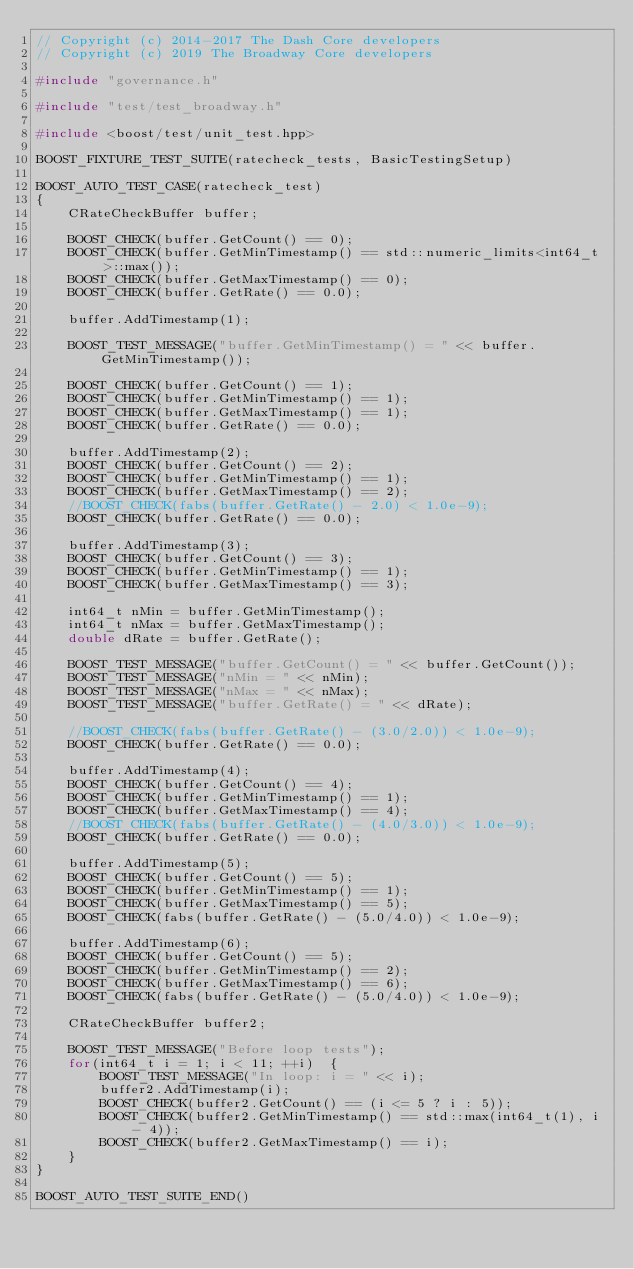Convert code to text. <code><loc_0><loc_0><loc_500><loc_500><_C++_>// Copyright (c) 2014-2017 The Dash Core developers
// Copyright (c) 2019 The Broadway Core developers

#include "governance.h"

#include "test/test_broadway.h"

#include <boost/test/unit_test.hpp>

BOOST_FIXTURE_TEST_SUITE(ratecheck_tests, BasicTestingSetup)

BOOST_AUTO_TEST_CASE(ratecheck_test)
{
    CRateCheckBuffer buffer;

    BOOST_CHECK(buffer.GetCount() == 0);
    BOOST_CHECK(buffer.GetMinTimestamp() == std::numeric_limits<int64_t>::max());
    BOOST_CHECK(buffer.GetMaxTimestamp() == 0);
    BOOST_CHECK(buffer.GetRate() == 0.0);

    buffer.AddTimestamp(1);

    BOOST_TEST_MESSAGE("buffer.GetMinTimestamp() = " << buffer.GetMinTimestamp());

    BOOST_CHECK(buffer.GetCount() == 1);
    BOOST_CHECK(buffer.GetMinTimestamp() == 1);
    BOOST_CHECK(buffer.GetMaxTimestamp() == 1);
    BOOST_CHECK(buffer.GetRate() == 0.0);

    buffer.AddTimestamp(2);
    BOOST_CHECK(buffer.GetCount() == 2);
    BOOST_CHECK(buffer.GetMinTimestamp() == 1);
    BOOST_CHECK(buffer.GetMaxTimestamp() == 2);
    //BOOST_CHECK(fabs(buffer.GetRate() - 2.0) < 1.0e-9);
    BOOST_CHECK(buffer.GetRate() == 0.0);

    buffer.AddTimestamp(3);
    BOOST_CHECK(buffer.GetCount() == 3);
    BOOST_CHECK(buffer.GetMinTimestamp() == 1);
    BOOST_CHECK(buffer.GetMaxTimestamp() == 3);

    int64_t nMin = buffer.GetMinTimestamp();
    int64_t nMax = buffer.GetMaxTimestamp();
    double dRate = buffer.GetRate();

    BOOST_TEST_MESSAGE("buffer.GetCount() = " << buffer.GetCount());
    BOOST_TEST_MESSAGE("nMin = " << nMin);
    BOOST_TEST_MESSAGE("nMax = " << nMax);
    BOOST_TEST_MESSAGE("buffer.GetRate() = " << dRate);

    //BOOST_CHECK(fabs(buffer.GetRate() - (3.0/2.0)) < 1.0e-9);
    BOOST_CHECK(buffer.GetRate() == 0.0);

    buffer.AddTimestamp(4);
    BOOST_CHECK(buffer.GetCount() == 4);
    BOOST_CHECK(buffer.GetMinTimestamp() == 1);
    BOOST_CHECK(buffer.GetMaxTimestamp() == 4);
    //BOOST_CHECK(fabs(buffer.GetRate() - (4.0/3.0)) < 1.0e-9);
    BOOST_CHECK(buffer.GetRate() == 0.0);

    buffer.AddTimestamp(5);
    BOOST_CHECK(buffer.GetCount() == 5);
    BOOST_CHECK(buffer.GetMinTimestamp() == 1);
    BOOST_CHECK(buffer.GetMaxTimestamp() == 5);
    BOOST_CHECK(fabs(buffer.GetRate() - (5.0/4.0)) < 1.0e-9);

    buffer.AddTimestamp(6);
    BOOST_CHECK(buffer.GetCount() == 5);
    BOOST_CHECK(buffer.GetMinTimestamp() == 2);
    BOOST_CHECK(buffer.GetMaxTimestamp() == 6);
    BOOST_CHECK(fabs(buffer.GetRate() - (5.0/4.0)) < 1.0e-9);

    CRateCheckBuffer buffer2;

    BOOST_TEST_MESSAGE("Before loop tests");
    for(int64_t i = 1; i < 11; ++i)  {
        BOOST_TEST_MESSAGE("In loop: i = " << i);
        buffer2.AddTimestamp(i);
        BOOST_CHECK(buffer2.GetCount() == (i <= 5 ? i : 5));
        BOOST_CHECK(buffer2.GetMinTimestamp() == std::max(int64_t(1), i - 4));
        BOOST_CHECK(buffer2.GetMaxTimestamp() == i);
    }
}

BOOST_AUTO_TEST_SUITE_END()
</code> 